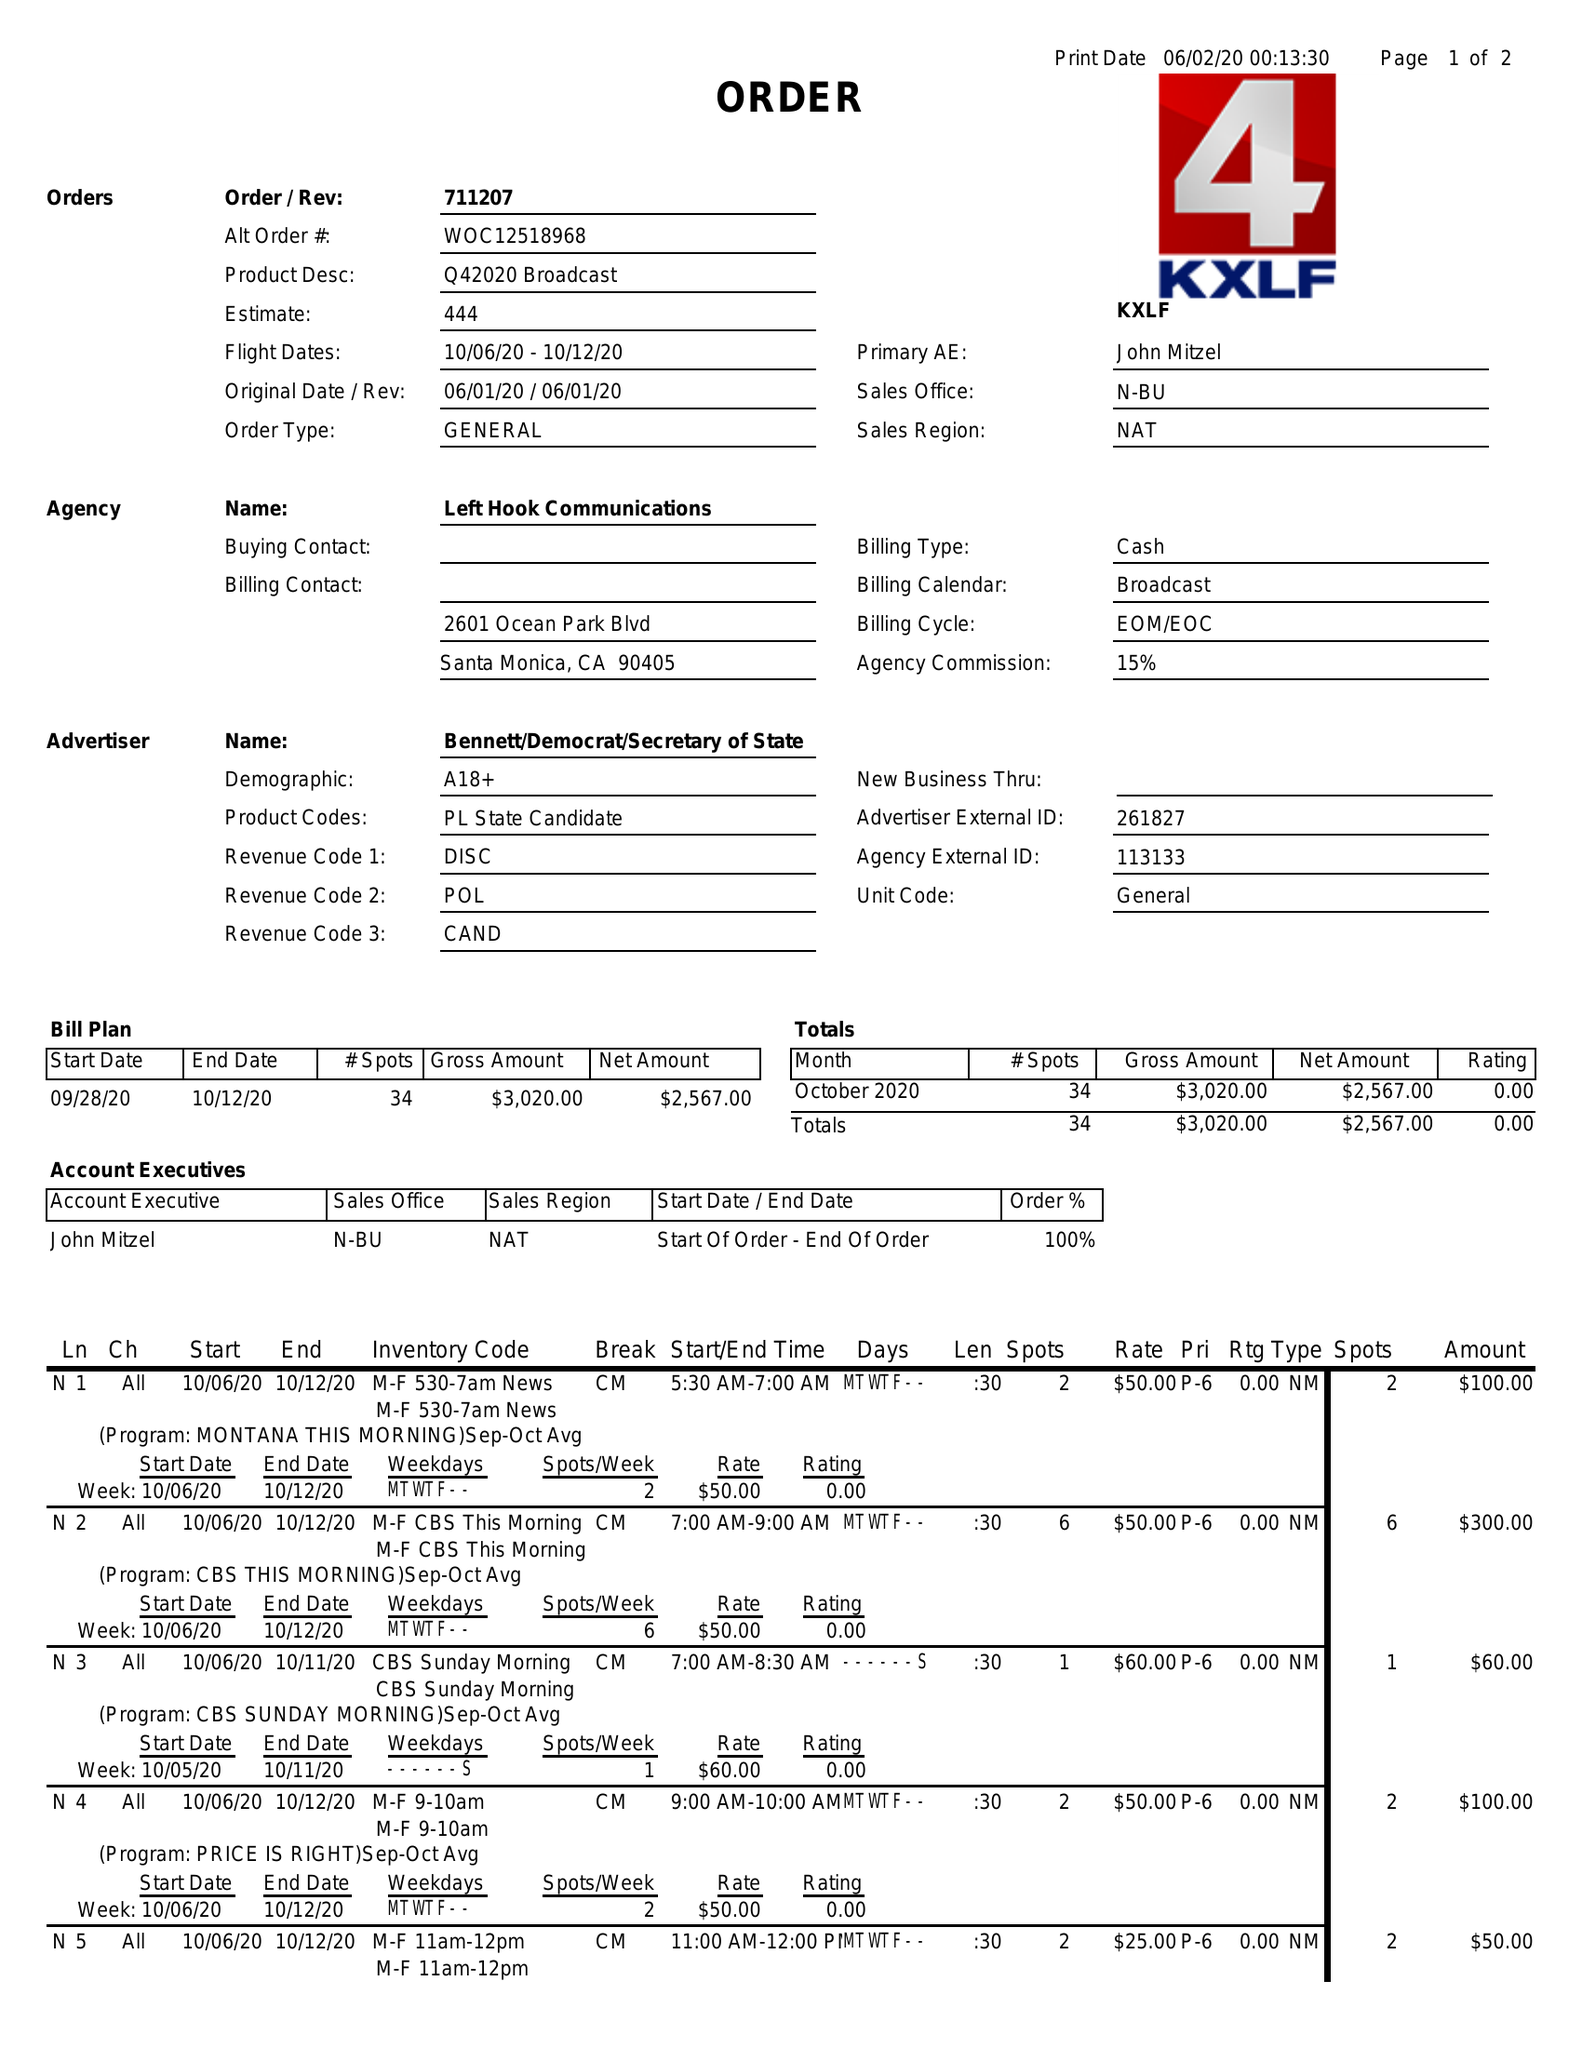What is the value for the gross_amount?
Answer the question using a single word or phrase. 3020.00 